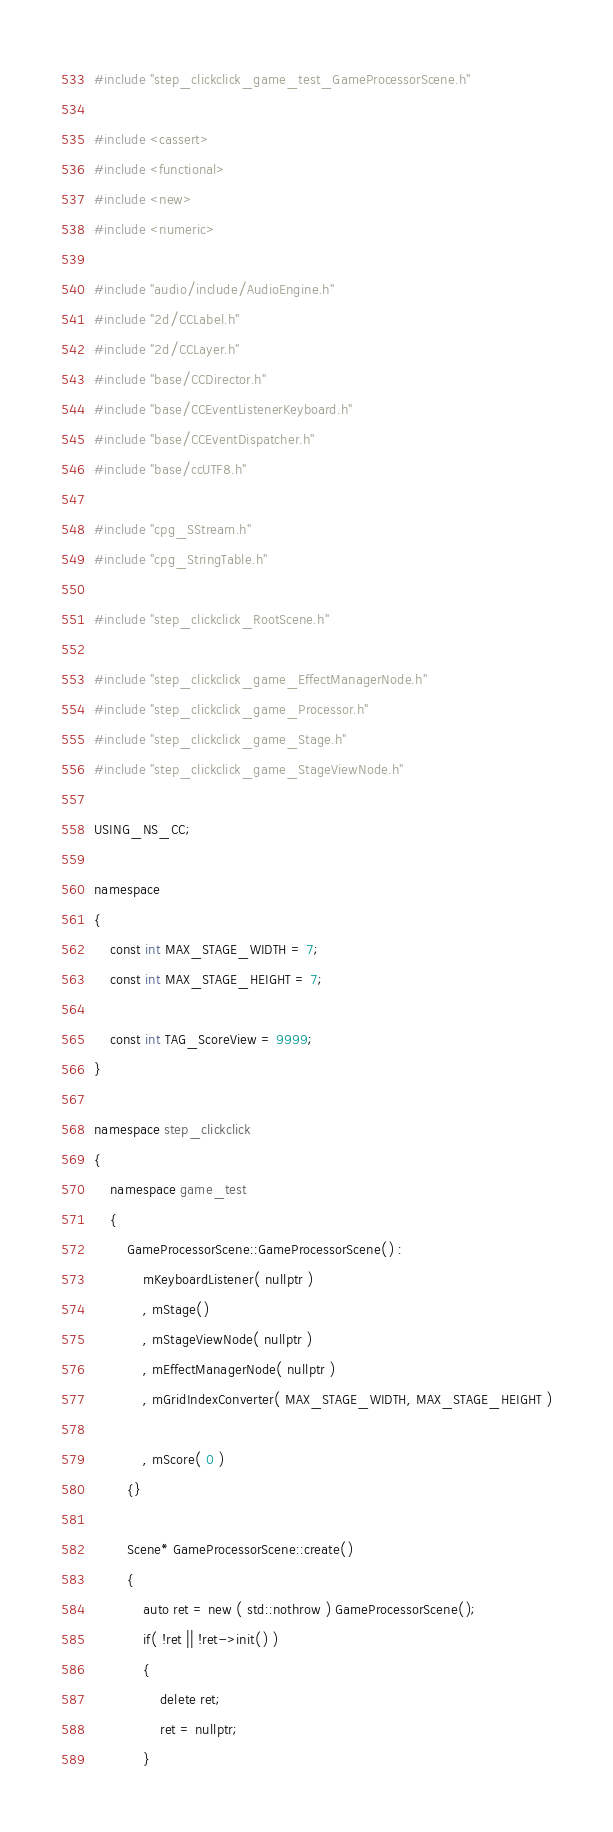<code> <loc_0><loc_0><loc_500><loc_500><_C++_>#include "step_clickclick_game_test_GameProcessorScene.h"

#include <cassert>
#include <functional>
#include <new>
#include <numeric>

#include "audio/include/AudioEngine.h"
#include "2d/CCLabel.h"
#include "2d/CCLayer.h"
#include "base/CCDirector.h"
#include "base/CCEventListenerKeyboard.h"
#include "base/CCEventDispatcher.h"
#include "base/ccUTF8.h"

#include "cpg_SStream.h"
#include "cpg_StringTable.h"

#include "step_clickclick_RootScene.h"

#include "step_clickclick_game_EffectManagerNode.h"
#include "step_clickclick_game_Processor.h"
#include "step_clickclick_game_Stage.h"
#include "step_clickclick_game_StageViewNode.h"

USING_NS_CC;

namespace
{
	const int MAX_STAGE_WIDTH = 7;
	const int MAX_STAGE_HEIGHT = 7;

	const int TAG_ScoreView = 9999;
}

namespace step_clickclick
{
	namespace game_test
	{
		GameProcessorScene::GameProcessorScene() :
			mKeyboardListener( nullptr )
			, mStage()
			, mStageViewNode( nullptr )
			, mEffectManagerNode( nullptr )
			, mGridIndexConverter( MAX_STAGE_WIDTH, MAX_STAGE_HEIGHT )

			, mScore( 0 )
		{}

		Scene* GameProcessorScene::create()
		{
			auto ret = new ( std::nothrow ) GameProcessorScene();
			if( !ret || !ret->init() )
			{
				delete ret;
				ret = nullptr;
			}</code> 